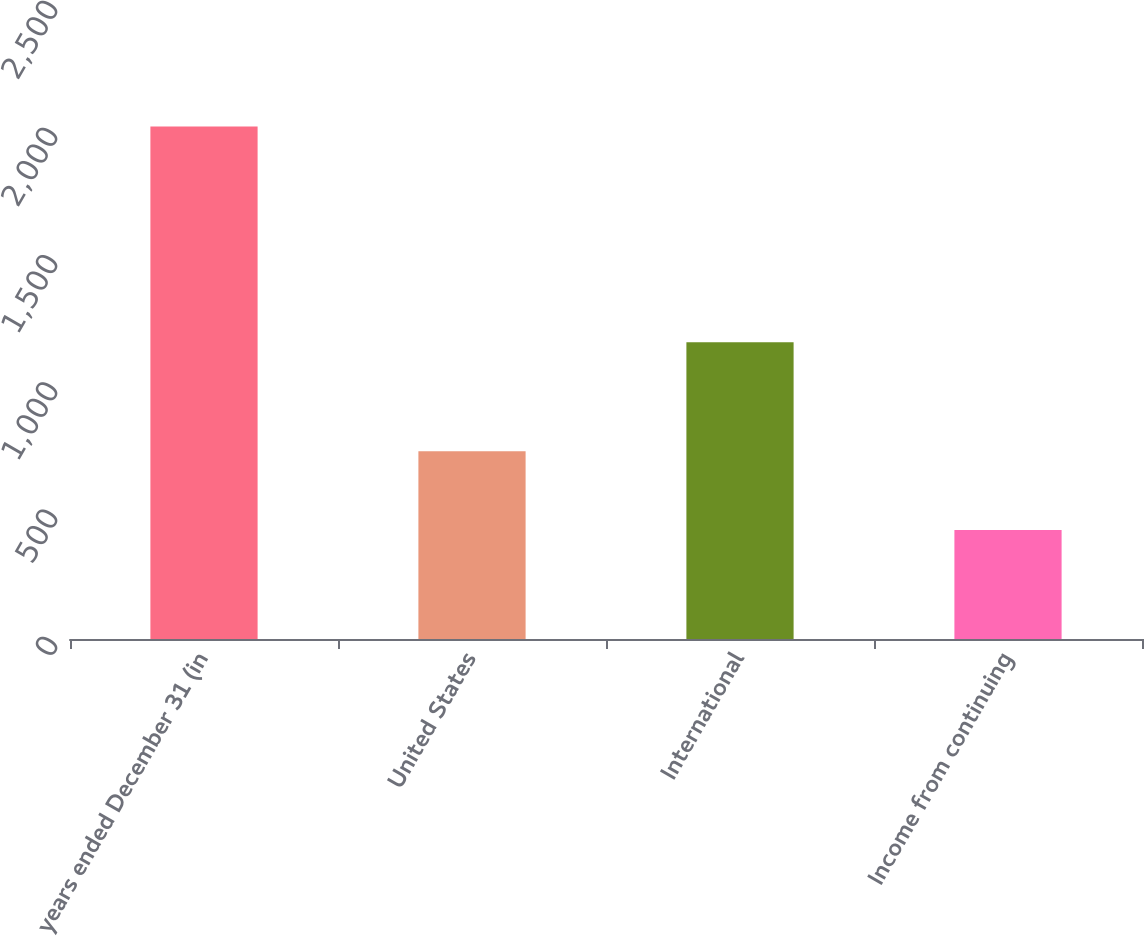Convert chart to OTSL. <chart><loc_0><loc_0><loc_500><loc_500><bar_chart><fcel>years ended December 31 (in<fcel>United States<fcel>International<fcel>Income from continuing<nl><fcel>2015<fcel>738<fcel>1166<fcel>428<nl></chart> 